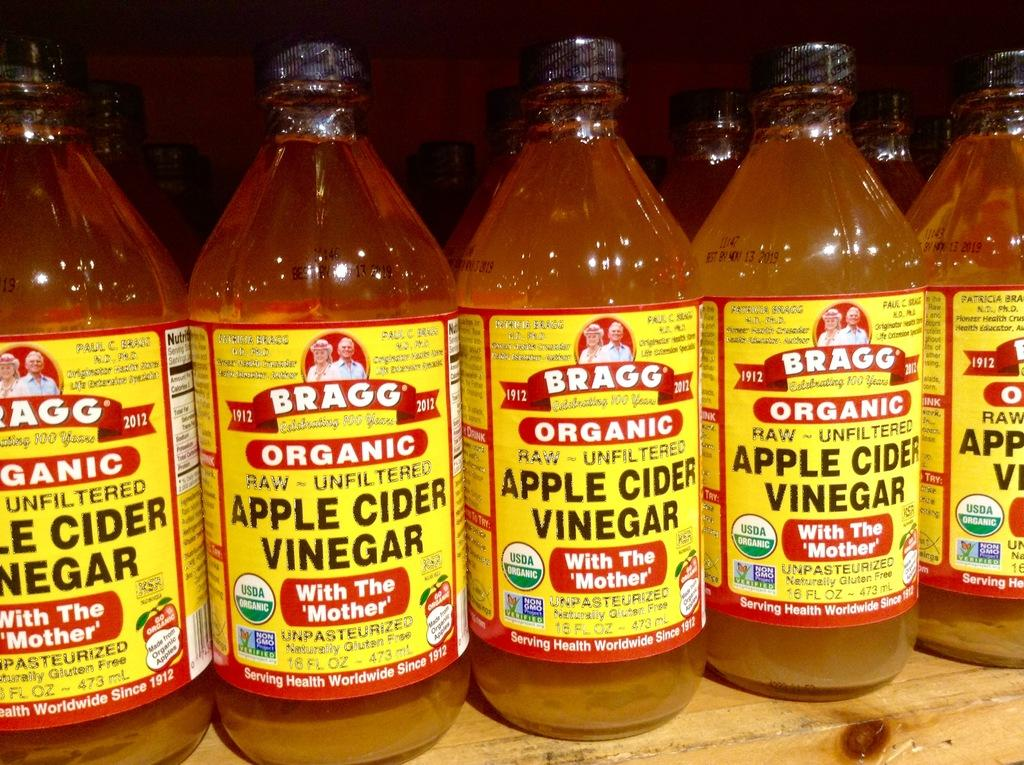<image>
Create a compact narrative representing the image presented. Bottles of Bragg brand organic apple cider vinegar stand next to each other on a store shelf. 